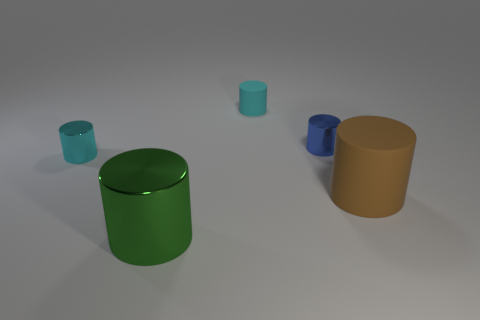How would you describe the lighting in this scene? The lighting appears diffuse, with soft shadows indicating a source of light that is not directly visible, providing an even illumination across the scene. Does the lighting affect the color perception of the objects? Yes, the lighting can influence how we perceive the colors, often making them appear less saturated and with less contrast between light and dark areas. 